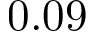<formula> <loc_0><loc_0><loc_500><loc_500>0 . 0 9</formula> 